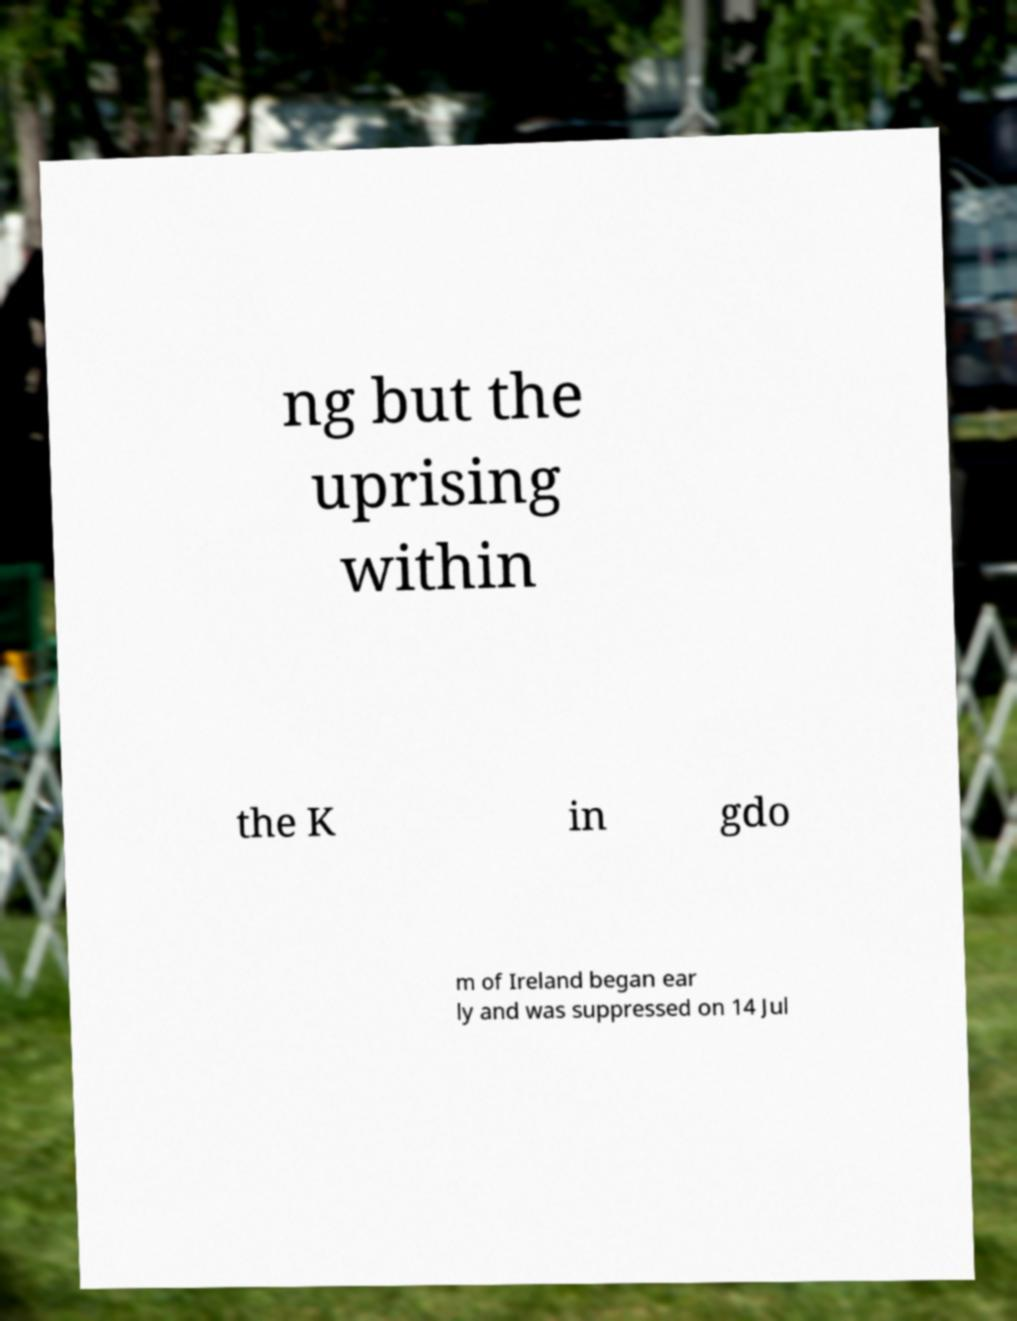There's text embedded in this image that I need extracted. Can you transcribe it verbatim? ng but the uprising within the K in gdo m of Ireland began ear ly and was suppressed on 14 Jul 